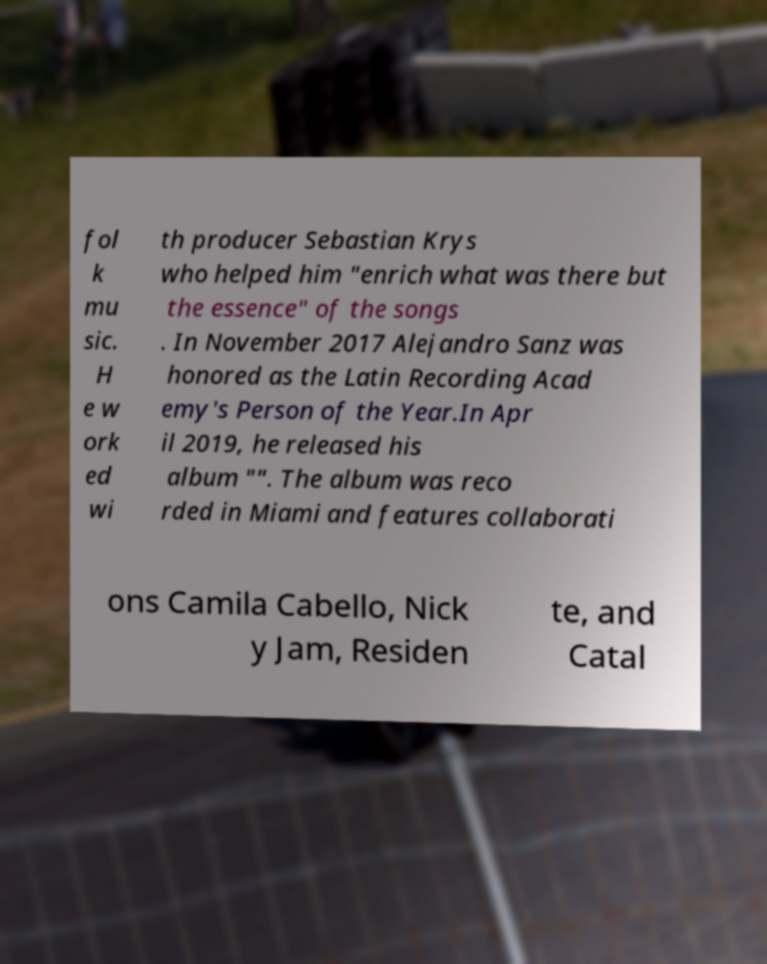Can you accurately transcribe the text from the provided image for me? fol k mu sic. H e w ork ed wi th producer Sebastian Krys who helped him "enrich what was there but the essence" of the songs . In November 2017 Alejandro Sanz was honored as the Latin Recording Acad emy's Person of the Year.In Apr il 2019, he released his album "". The album was reco rded in Miami and features collaborati ons Camila Cabello, Nick y Jam, Residen te, and Catal 